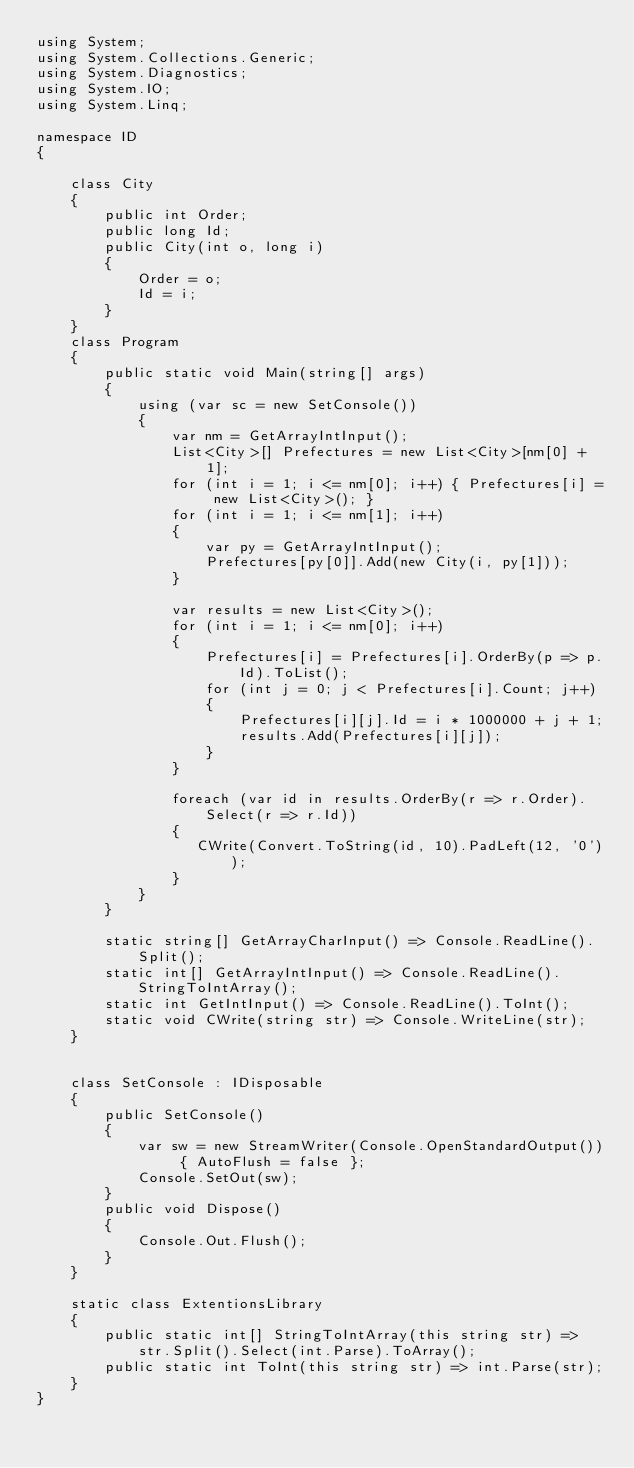Convert code to text. <code><loc_0><loc_0><loc_500><loc_500><_C#_>using System;
using System.Collections.Generic;
using System.Diagnostics;
using System.IO;
using System.Linq;

namespace ID
{

    class City
    {
        public int Order;
        public long Id;
        public City(int o, long i)
        {
            Order = o;
            Id = i;
        }
    }
    class Program
    {
        public static void Main(string[] args)
        {
            using (var sc = new SetConsole())
            {
                var nm = GetArrayIntInput();
                List<City>[] Prefectures = new List<City>[nm[0] + 1];
                for (int i = 1; i <= nm[0]; i++) { Prefectures[i] = new List<City>(); }
                for (int i = 1; i <= nm[1]; i++)
                {
                    var py = GetArrayIntInput();
                    Prefectures[py[0]].Add(new City(i, py[1]));
                }

                var results = new List<City>();
                for (int i = 1; i <= nm[0]; i++)
                {
                    Prefectures[i] = Prefectures[i].OrderBy(p => p.Id).ToList();
                    for (int j = 0; j < Prefectures[i].Count; j++)
                    {
                        Prefectures[i][j].Id = i * 1000000 + j + 1;
                        results.Add(Prefectures[i][j]);
                    }
                }

                foreach (var id in results.OrderBy(r => r.Order).Select(r => r.Id))
                {
                   CWrite(Convert.ToString(id, 10).PadLeft(12, '0'));
                }
            }
        }

        static string[] GetArrayCharInput() => Console.ReadLine().Split();
        static int[] GetArrayIntInput() => Console.ReadLine().StringToIntArray();
        static int GetIntInput() => Console.ReadLine().ToInt();
        static void CWrite(string str) => Console.WriteLine(str);
    }
    

    class SetConsole : IDisposable
    {
        public SetConsole()
        {
            var sw = new StreamWriter(Console.OpenStandardOutput()) { AutoFlush = false };
            Console.SetOut(sw);
        }
        public void Dispose()
        {
            Console.Out.Flush();
        }
    }

    static class ExtentionsLibrary
    {
        public static int[] StringToIntArray(this string str) =>
            str.Split().Select(int.Parse).ToArray();
        public static int ToInt(this string str) => int.Parse(str);
    }
}
</code> 